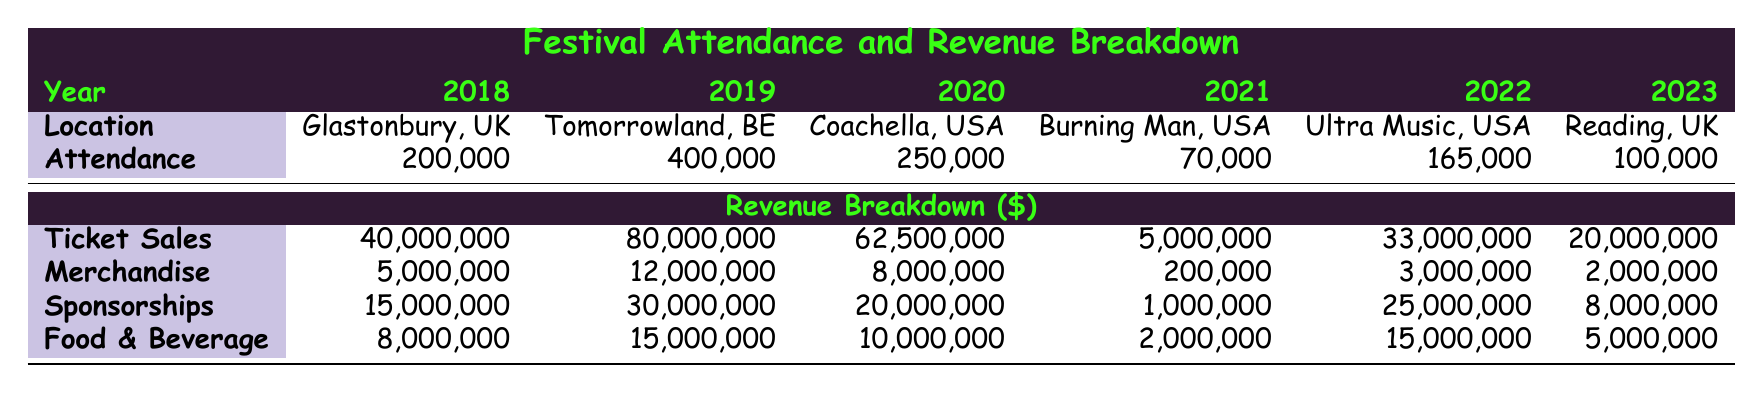What was the location of the festival with the highest attendance? The table shows that Tomorrowland in Belgium in 2019 had the highest attendance at 400,000.
Answer: Tomorrowland, Belgium What was the total revenue from ticket sales in 2022? According to the table, the ticket sales revenue for Ultra Music Festival in 2022 was 33,000,000.
Answer: 33,000,000 Is the total revenue from food and beverage sales in 2020 greater than that in 2023? The food and beverage revenue in 2020 is 10,000,000 while in 2023 it is 5,000,000. Since 10,000,000 is greater than 5,000,000, the statement is true.
Answer: Yes What is the total revenue for all festivals in 2018? The revenues for Glastonbury in 2018 from different sources are: 40,000,000 (Ticket Sales) + 5,000,000 (Merchandise) + 15,000,000 (Sponsorships) + 8,000,000 (Food & Beverage) summing up to 68,000,000.
Answer: 68,000,000 Which year had the lowest merchandise sales? The table indicates that in 2021, merchandise sales for Burning Man amounted to only 200,000, which is less than any other year listed.
Answer: 2021 What was the increase in attendance from 2021 to 2022? The attendance in 2021 was 70,000 and in 2022 it was 165,000. The increase can be calculated as 165,000 - 70,000 = 95,000.
Answer: 95,000 Is the total revenue from sponsorships in 2019 higher than in 2023? The sponsorship revenue for Tomorrowland in 2019 is 30,000,000, while for Reading Festival in 2023 it is 8,000,000. Since 30,000,000 is greater than 8,000,000, the statement is true.
Answer: Yes What is the average attendance over all listed festivals? The total attendance from all festivals listed is 200,000 + 400,000 + 250,000 + 70,000 + 165,000 + 100,000 = 1,185,000. There are 6 festivals, so the average attendance is 1,185,000 / 6 = 197,500.
Answer: 197,500 Which festival had the highest revenue from merchandise sales? The merchandise revenue for Tomorrowland in 2019 is 12,000,000, which is higher than all other years, making it the highest revenue from merchandise sales.
Answer: Tomorrowland, Belgium 